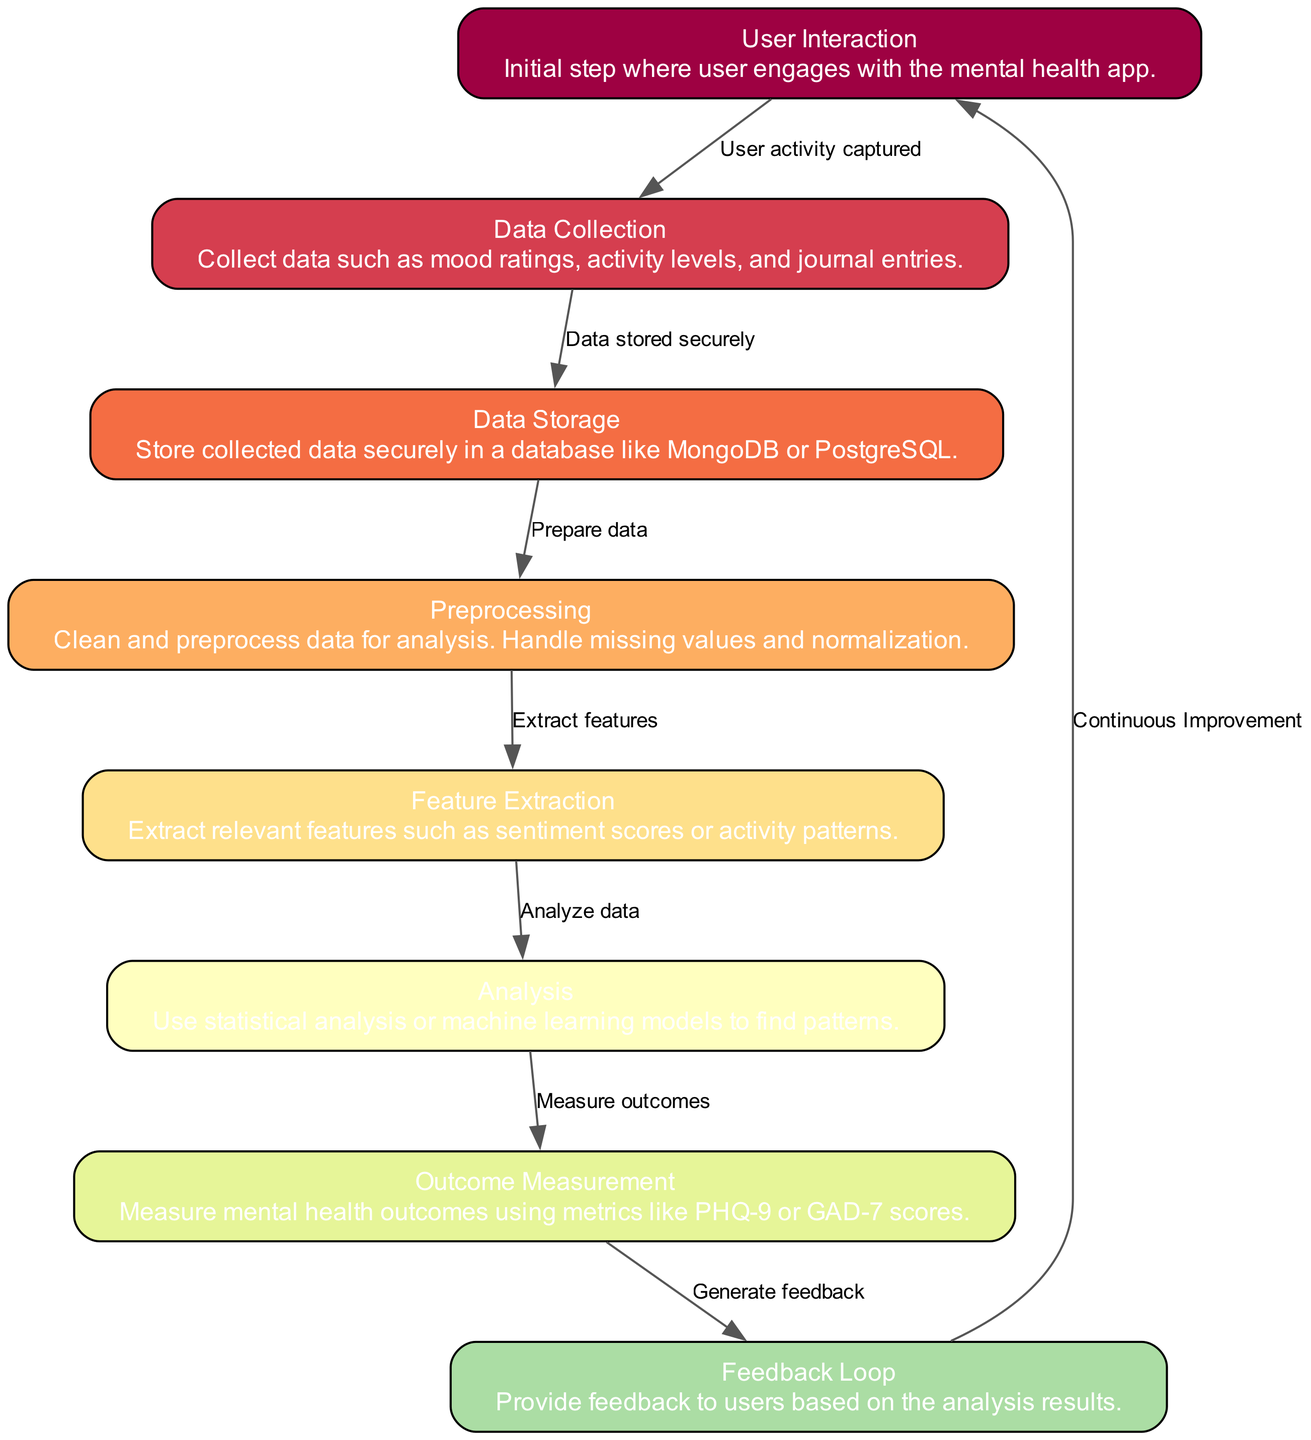What is the first step of the process in the diagram? The diagram begins with the node labeled "User Interaction," indicating that this is the initial step where the user engages with the mental health app.
Answer: User Interaction How many nodes are present in the diagram? By counting the nodes listed in the data, we see there are a total of 8 distinct nodes represented in the flowchart.
Answer: 8 What type of data is collected in the "Data Collection" node? The "Data Collection" node specifically mentions collecting data such as mood ratings, activity levels, and journal entries, indicating the types of user input that is relevant to mental health tracking.
Answer: Mood ratings, activity levels, journal entries What happens after the "Analysis" step? The "Analysis" node leads to the "Outcome Measurement" node, which indicates that after analyzing the data, the next step is to measure mental health outcomes using specific metrics.
Answer: Measure mental health outcomes What is the purpose of the "Feedback Loop" node? The "Feedback Loop" node indicates that feedback is provided to users based on the analysis results, showing that this step is critical for user engagement and improvement in mental health outcomes.
Answer: Provide feedback Which node indicates data storage? The "Data Storage" node specifically denotes the secure storage of collected data in a database, representing the safeguarding of user information and analysis readiness.
Answer: Data Storage What is the last step in the process represented in the diagram? The final node in the flowchart is the "Feedback Loop," which illustrates the continuous improvement aspect by looping back to "User Interaction" to enhance user experience and outcomes.
Answer: Feedback Loop What type of analysis is conducted after feature extraction? After the "Feature Extraction" node, the "Analysis" step takes place, where statistical analysis or machine learning models are used to uncover patterns in the data collected from users.
Answer: Statistical analysis or machine learning models What indicates the transition from data storage to preprocessing? The edge connecting "Data Storage" to "Preprocessing" is labeled "Prepare data," indicating the transition from stored data to the next preparatory step for analysis.
Answer: Prepare data 